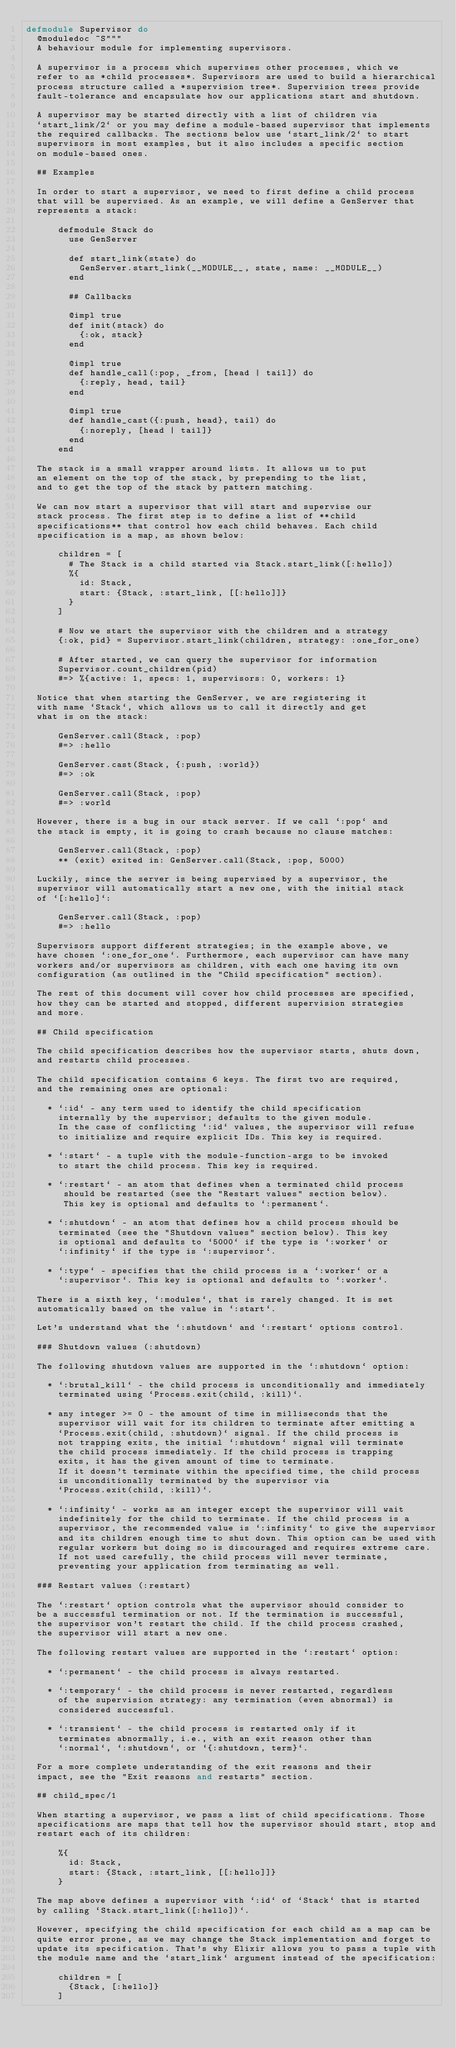Convert code to text. <code><loc_0><loc_0><loc_500><loc_500><_Elixir_>defmodule Supervisor do
  @moduledoc ~S"""
  A behaviour module for implementing supervisors.

  A supervisor is a process which supervises other processes, which we
  refer to as *child processes*. Supervisors are used to build a hierarchical
  process structure called a *supervision tree*. Supervision trees provide
  fault-tolerance and encapsulate how our applications start and shutdown.

  A supervisor may be started directly with a list of children via
  `start_link/2` or you may define a module-based supervisor that implements
  the required callbacks. The sections below use `start_link/2` to start
  supervisors in most examples, but it also includes a specific section
  on module-based ones.

  ## Examples

  In order to start a supervisor, we need to first define a child process
  that will be supervised. As an example, we will define a GenServer that
  represents a stack:

      defmodule Stack do
        use GenServer

        def start_link(state) do
          GenServer.start_link(__MODULE__, state, name: __MODULE__)
        end

        ## Callbacks

        @impl true
        def init(stack) do
          {:ok, stack}
        end

        @impl true
        def handle_call(:pop, _from, [head | tail]) do
          {:reply, head, tail}
        end

        @impl true
        def handle_cast({:push, head}, tail) do
          {:noreply, [head | tail]}
        end
      end

  The stack is a small wrapper around lists. It allows us to put
  an element on the top of the stack, by prepending to the list,
  and to get the top of the stack by pattern matching.

  We can now start a supervisor that will start and supervise our
  stack process. The first step is to define a list of **child
  specifications** that control how each child behaves. Each child
  specification is a map, as shown below:

      children = [
        # The Stack is a child started via Stack.start_link([:hello])
        %{
          id: Stack,
          start: {Stack, :start_link, [[:hello]]}
        }
      ]

      # Now we start the supervisor with the children and a strategy
      {:ok, pid} = Supervisor.start_link(children, strategy: :one_for_one)

      # After started, we can query the supervisor for information
      Supervisor.count_children(pid)
      #=> %{active: 1, specs: 1, supervisors: 0, workers: 1}

  Notice that when starting the GenServer, we are registering it
  with name `Stack`, which allows us to call it directly and get
  what is on the stack:

      GenServer.call(Stack, :pop)
      #=> :hello

      GenServer.cast(Stack, {:push, :world})
      #=> :ok

      GenServer.call(Stack, :pop)
      #=> :world

  However, there is a bug in our stack server. If we call `:pop` and
  the stack is empty, it is going to crash because no clause matches:

      GenServer.call(Stack, :pop)
      ** (exit) exited in: GenServer.call(Stack, :pop, 5000)

  Luckily, since the server is being supervised by a supervisor, the
  supervisor will automatically start a new one, with the initial stack
  of `[:hello]`:

      GenServer.call(Stack, :pop)
      #=> :hello

  Supervisors support different strategies; in the example above, we
  have chosen `:one_for_one`. Furthermore, each supervisor can have many
  workers and/or supervisors as children, with each one having its own
  configuration (as outlined in the "Child specification" section).

  The rest of this document will cover how child processes are specified,
  how they can be started and stopped, different supervision strategies
  and more.

  ## Child specification

  The child specification describes how the supervisor starts, shuts down,
  and restarts child processes.

  The child specification contains 6 keys. The first two are required,
  and the remaining ones are optional:

    * `:id` - any term used to identify the child specification
      internally by the supervisor; defaults to the given module.
      In the case of conflicting `:id` values, the supervisor will refuse
      to initialize and require explicit IDs. This key is required.

    * `:start` - a tuple with the module-function-args to be invoked
      to start the child process. This key is required.

    * `:restart` - an atom that defines when a terminated child process
       should be restarted (see the "Restart values" section below).
       This key is optional and defaults to `:permanent`.

    * `:shutdown` - an atom that defines how a child process should be
      terminated (see the "Shutdown values" section below). This key
      is optional and defaults to `5000` if the type is `:worker` or
      `:infinity` if the type is `:supervisor`.

    * `:type` - specifies that the child process is a `:worker` or a
      `:supervisor`. This key is optional and defaults to `:worker`.

  There is a sixth key, `:modules`, that is rarely changed. It is set
  automatically based on the value in `:start`.

  Let's understand what the `:shutdown` and `:restart` options control.

  ### Shutdown values (:shutdown)

  The following shutdown values are supported in the `:shutdown` option:

    * `:brutal_kill` - the child process is unconditionally and immediately
      terminated using `Process.exit(child, :kill)`.

    * any integer >= 0 - the amount of time in milliseconds that the
      supervisor will wait for its children to terminate after emitting a
      `Process.exit(child, :shutdown)` signal. If the child process is
      not trapping exits, the initial `:shutdown` signal will terminate
      the child process immediately. If the child process is trapping
      exits, it has the given amount of time to terminate.
      If it doesn't terminate within the specified time, the child process
      is unconditionally terminated by the supervisor via
      `Process.exit(child, :kill)`.

    * `:infinity` - works as an integer except the supervisor will wait
      indefinitely for the child to terminate. If the child process is a
      supervisor, the recommended value is `:infinity` to give the supervisor
      and its children enough time to shut down. This option can be used with
      regular workers but doing so is discouraged and requires extreme care.
      If not used carefully, the child process will never terminate,
      preventing your application from terminating as well.

  ### Restart values (:restart)

  The `:restart` option controls what the supervisor should consider to
  be a successful termination or not. If the termination is successful,
  the supervisor won't restart the child. If the child process crashed,
  the supervisor will start a new one.

  The following restart values are supported in the `:restart` option:

    * `:permanent` - the child process is always restarted.

    * `:temporary` - the child process is never restarted, regardless
      of the supervision strategy: any termination (even abnormal) is
      considered successful.

    * `:transient` - the child process is restarted only if it
      terminates abnormally, i.e., with an exit reason other than
      `:normal`, `:shutdown`, or `{:shutdown, term}`.

  For a more complete understanding of the exit reasons and their
  impact, see the "Exit reasons and restarts" section.

  ## child_spec/1

  When starting a supervisor, we pass a list of child specifications. Those
  specifications are maps that tell how the supervisor should start, stop and
  restart each of its children:

      %{
        id: Stack,
        start: {Stack, :start_link, [[:hello]]}
      }

  The map above defines a supervisor with `:id` of `Stack` that is started
  by calling `Stack.start_link([:hello])`.

  However, specifying the child specification for each child as a map can be
  quite error prone, as we may change the Stack implementation and forget to
  update its specification. That's why Elixir allows you to pass a tuple with
  the module name and the `start_link` argument instead of the specification:

      children = [
        {Stack, [:hello]}
      ]
</code> 